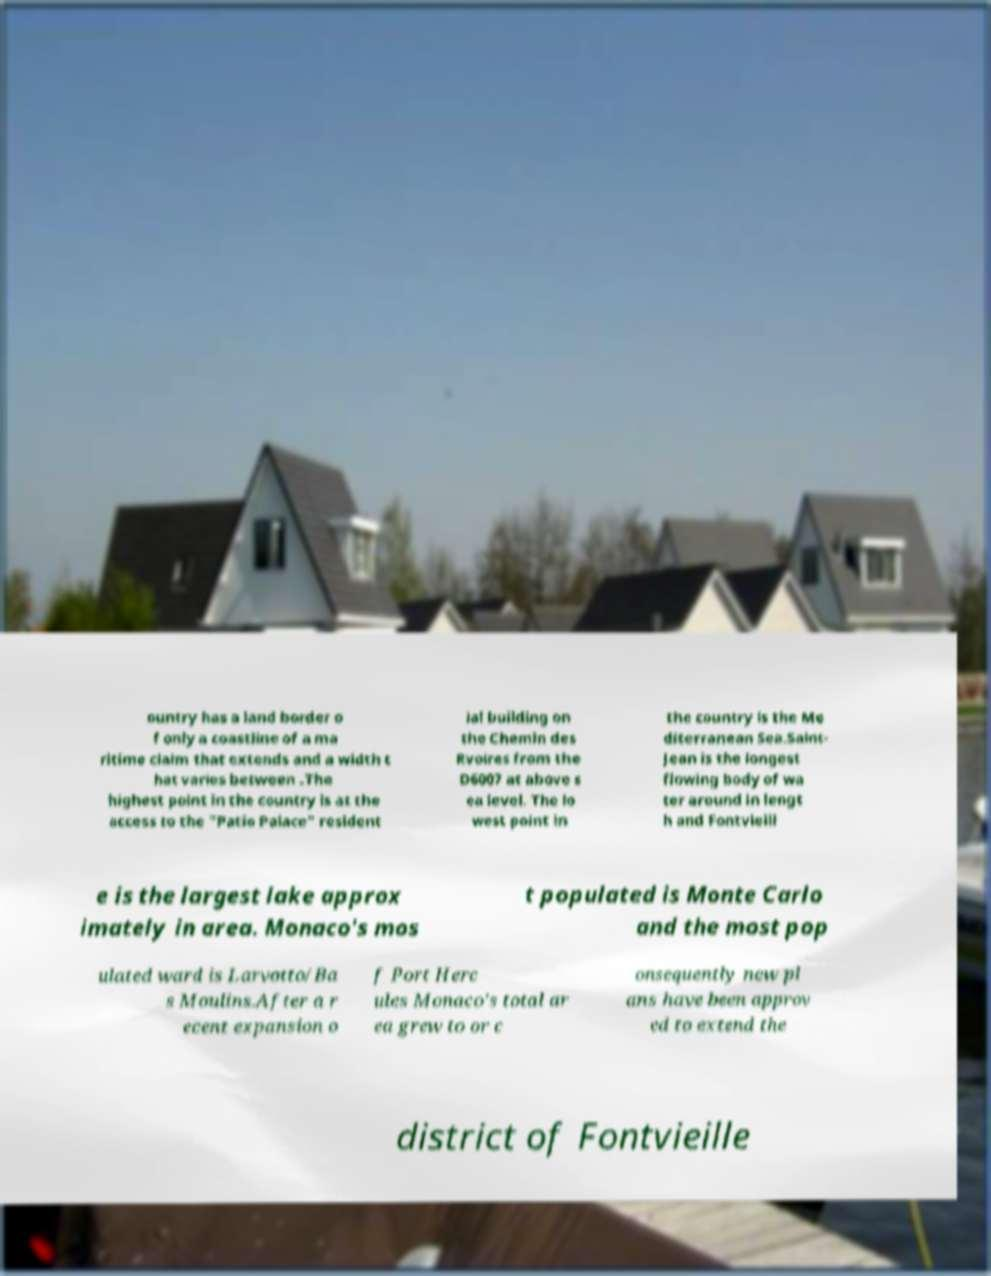Please identify and transcribe the text found in this image. ountry has a land border o f only a coastline of a ma ritime claim that extends and a width t hat varies between .The highest point in the country is at the access to the "Patio Palace" resident ial building on the Chemin des Rvoires from the D6007 at above s ea level. The lo west point in the country is the Me diterranean Sea.Saint- Jean is the longest flowing body of wa ter around in lengt h and Fontvieill e is the largest lake approx imately in area. Monaco's mos t populated is Monte Carlo and the most pop ulated ward is Larvotto/Ba s Moulins.After a r ecent expansion o f Port Herc ules Monaco's total ar ea grew to or c onsequently new pl ans have been approv ed to extend the district of Fontvieille 